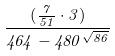Convert formula to latex. <formula><loc_0><loc_0><loc_500><loc_500>\frac { ( \frac { 7 } { 5 1 } \cdot 3 ) } { 4 6 4 - 4 8 0 ^ { \sqrt { 8 6 } } }</formula> 